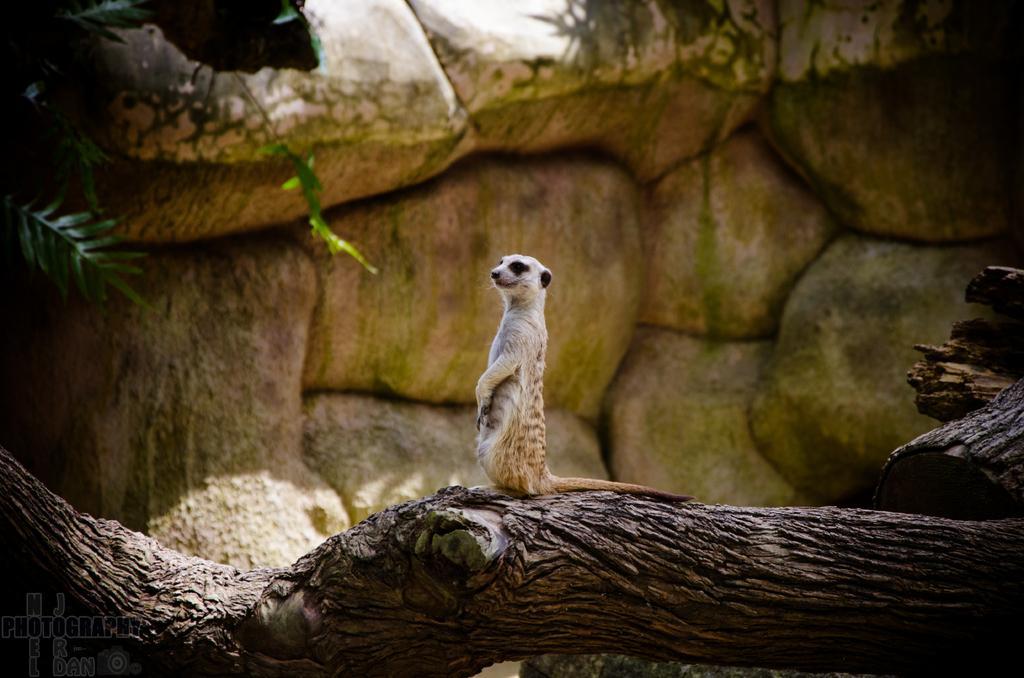Please provide a concise description of this image. In this picture I can see there is a animal sitting on the trunk of tree and in the background there are some rocks and plants. 